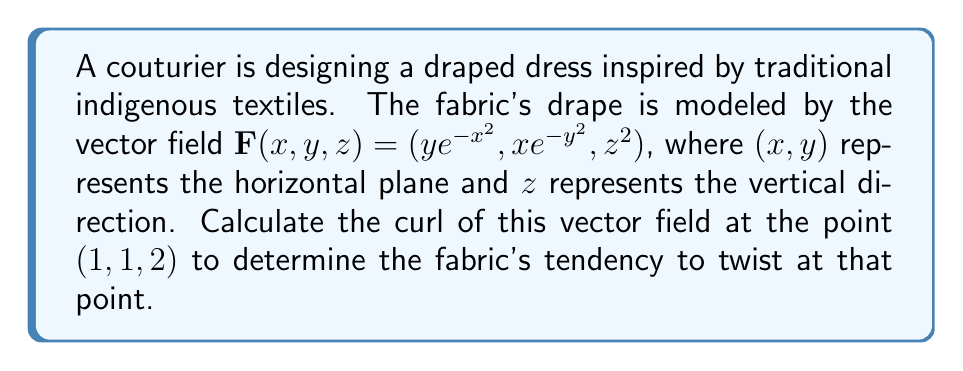What is the answer to this math problem? To find the curl of the vector field, we need to follow these steps:

1) The curl of a vector field $\mathbf{F}(x,y,z) = (F_1, F_2, F_3)$ is defined as:

   $$\text{curl }\mathbf{F} = \nabla \times \mathbf{F} = \left(\frac{\partial F_3}{\partial y} - \frac{\partial F_2}{\partial z}, \frac{\partial F_1}{\partial z} - \frac{\partial F_3}{\partial x}, \frac{\partial F_2}{\partial x} - \frac{\partial F_1}{\partial y}\right)$$

2) For our vector field $\mathbf{F}(x,y,z) = (ye^{-x^2}, xe^{-y^2}, z^2)$, we have:
   $F_1 = ye^{-x^2}$
   $F_2 = xe^{-y^2}$
   $F_3 = z^2$

3) Let's calculate each component of the curl:

   a) $\frac{\partial F_3}{\partial y} - \frac{\partial F_2}{\partial z} = 0 - 0 = 0$

   b) $\frac{\partial F_1}{\partial z} - \frac{\partial F_3}{\partial x} = 0 - 0 = 0$

   c) $\frac{\partial F_2}{\partial x} - \frac{\partial F_1}{\partial y} = e^{-y^2} - (e^{-x^2} - 2x^2ye^{-x^2})$

4) Therefore, the curl is:
   $$\text{curl }\mathbf{F} = (0, 0, e^{-y^2} - e^{-x^2} + 2x^2ye^{-x^2})$$

5) At the point $(1,1,2)$, we have:
   $$\text{curl }\mathbf{F}(1,1,2) = (0, 0, e^{-1} - e^{-1} + 2e^{-1}) = (0, 0, 2e^{-1})$$

This result indicates that at the point (1,1,2), the fabric has a tendency to twist around the z-axis with a magnitude of $2e^{-1}$.
Answer: $(0, 0, 2e^{-1})$ 